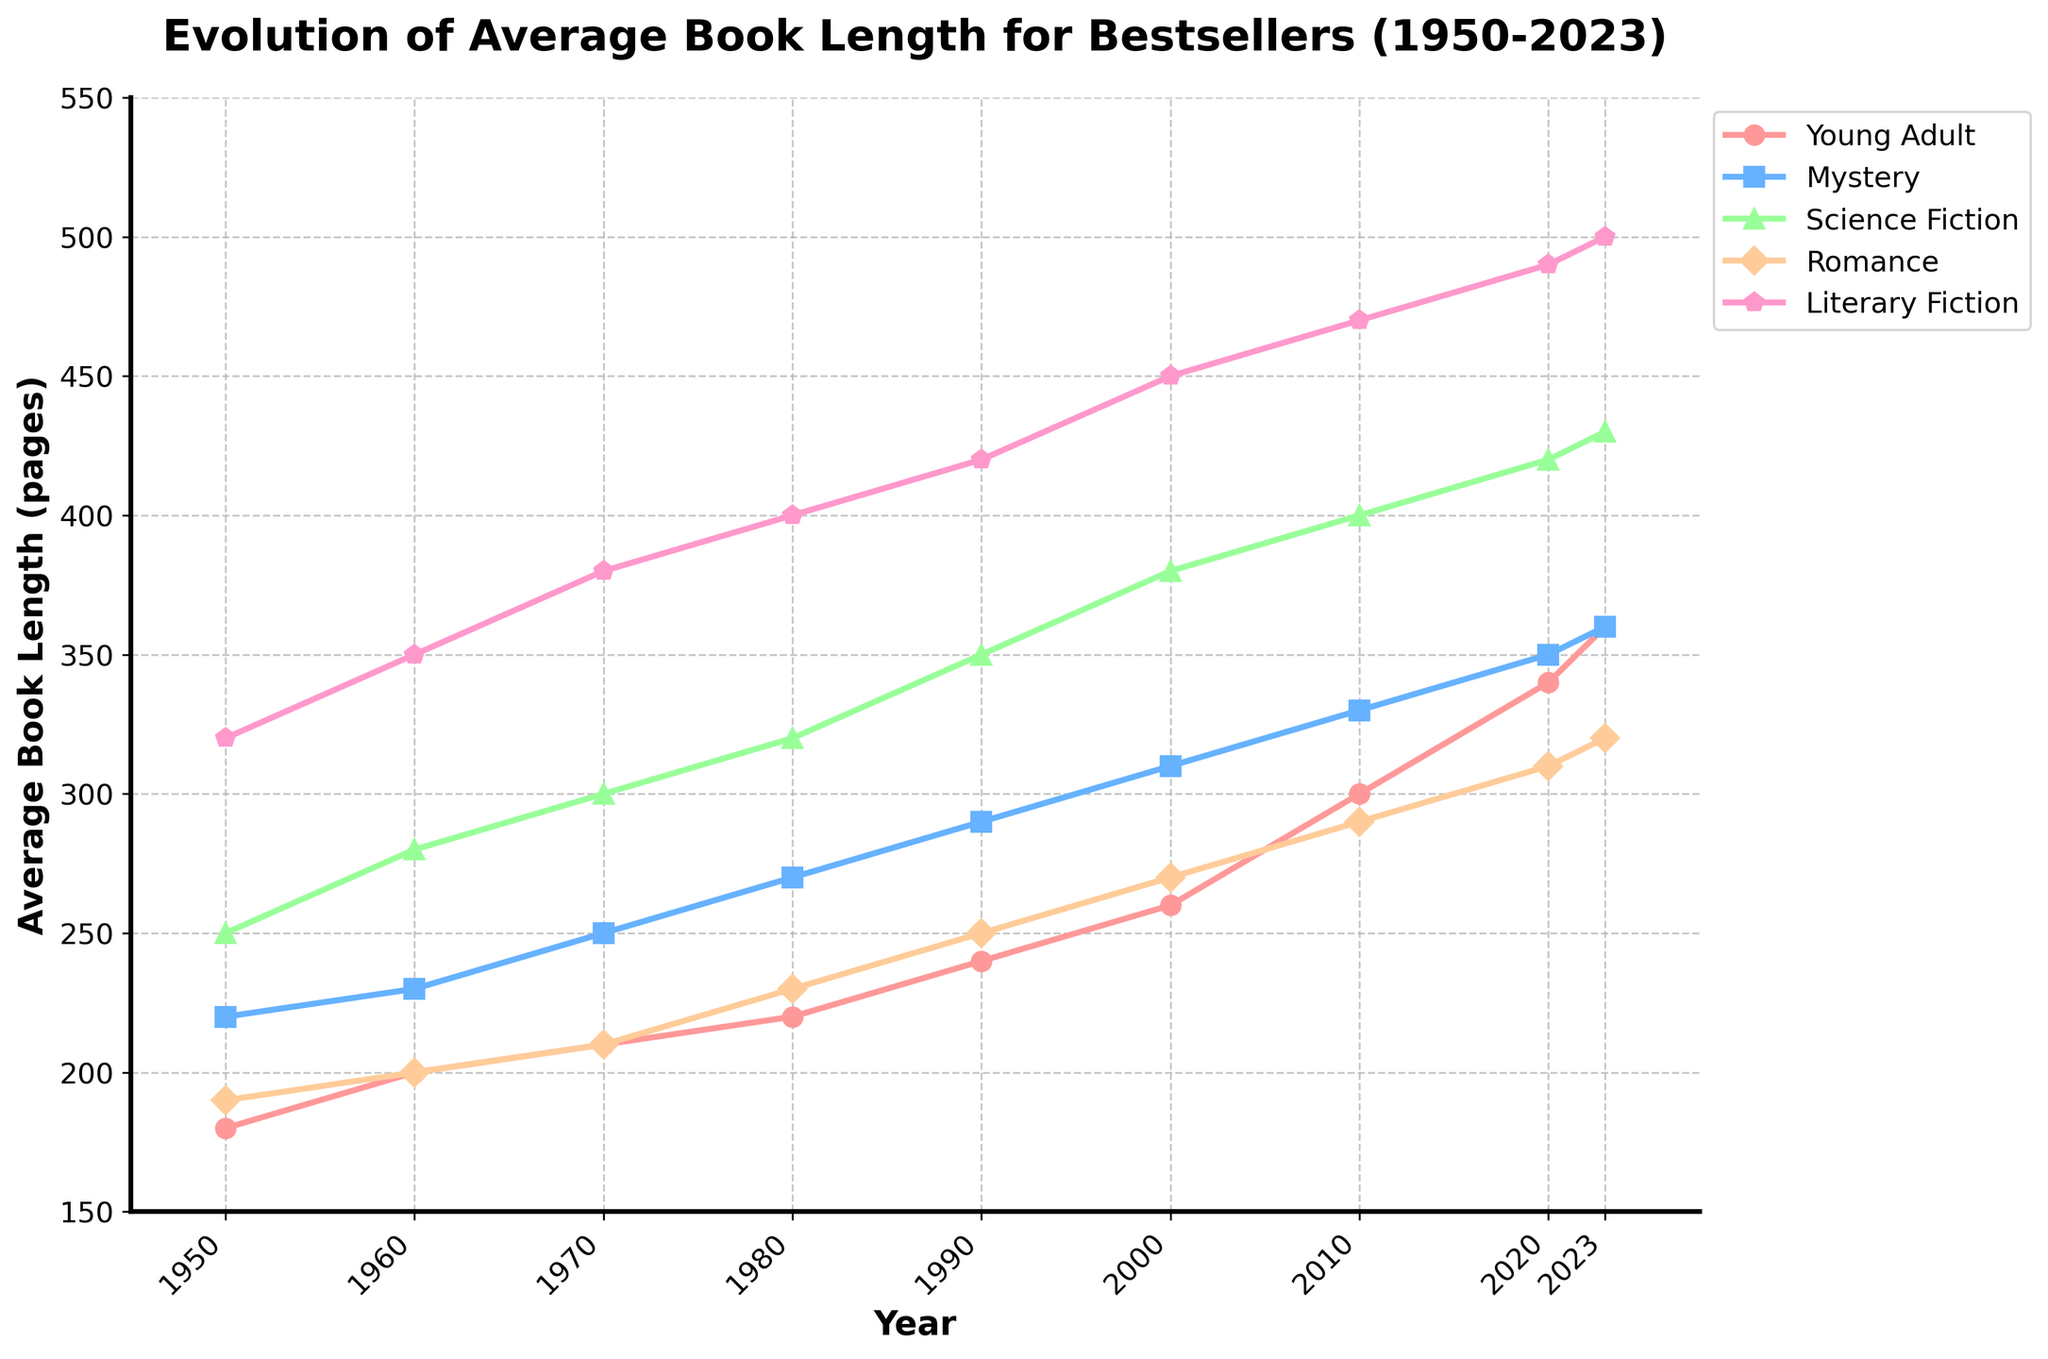Which genre shows the largest increase in average book length from 1950 to 2023? By looking at the chart, check the difference between the average book length values in 2023 and 1950 for each genre. The largest difference belongs to Literary Fiction, which increased from 320 pages in 1950 to 500 pages in 2023.
Answer: Literary Fiction In what year did Young Adult books first exceed an average length of 300 pages? Observe when the marker of Young Adult genre first crosses the 300 pages line. It happens in 2010.
Answer: 2010 Which genre had the smallest increase in average book length since 1950? Calculate the difference between 1950 and 2023 values for each genre: Young Adult increased by 180, Mystery by 140, Science Fiction by 180, Romance by 130, and Literary Fiction by 180. The genre with the smallest increase is Romance.
Answer: Romance What's the difference in the average book length between Science Fiction and Romance genres in the year 2023? Find the values for Science Fiction (430 pages) and Romance (320 pages) in 2023, and calculate the difference: 430 - 320 = 110 pages.
Answer: 110 pages Which genre was the longest on average in 1980? Refer to the chart in 1980 and find the highest data point among the genres. Literary Fiction had the highest average length with 400 pages.
Answer: Literary Fiction How has the average length of Mystery books changed from 2000 to 2020? Compare the average lengths of Mystery books in 2000 (310 pages) and in 2020 (350 pages). The difference is 350 - 310 = 40 pages.
Answer: 40 pages Which genre increased its average book length the most between 2010 and 2020? Check the values for each genre in 2010 and 2020, then calculate the differences: Young Adult = 40, Mystery = 20, Science Fiction = 20, Romance = 20, Literary Fiction = 20. Young Adult increased the most by 40 pages.
Answer: Young Adult By how much did the average book length for Romance books increase from 1980 to 2023? Compare the values for Romance books in 1980 (230 pages) and 2023 (320 pages). The difference is 320 - 230 = 90 pages.
Answer: 90 pages What is the average length of Science Fiction books in 1990? Look at the data point for Science Fiction in the year 1990, which shows an average length of 350 pages.
Answer: 350 pages 